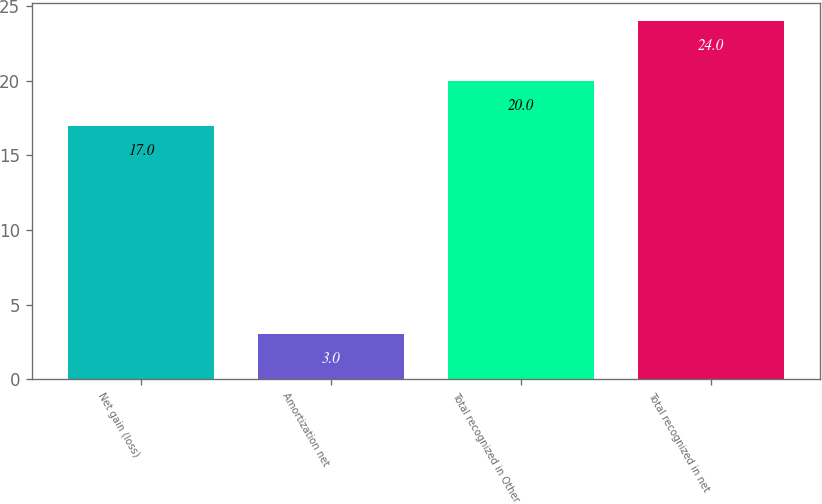Convert chart to OTSL. <chart><loc_0><loc_0><loc_500><loc_500><bar_chart><fcel>Net gain (loss)<fcel>Amortization net<fcel>Total recognized in Other<fcel>Total recognized in net<nl><fcel>17<fcel>3<fcel>20<fcel>24<nl></chart> 